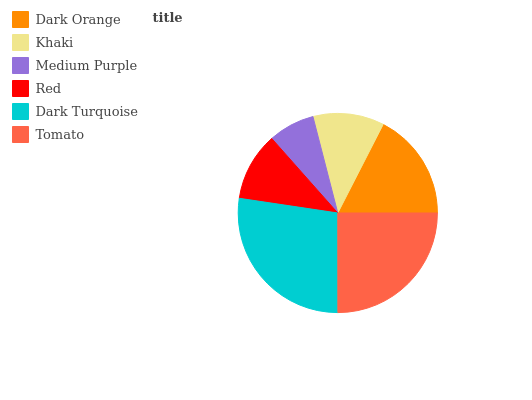Is Medium Purple the minimum?
Answer yes or no. Yes. Is Dark Turquoise the maximum?
Answer yes or no. Yes. Is Khaki the minimum?
Answer yes or no. No. Is Khaki the maximum?
Answer yes or no. No. Is Dark Orange greater than Khaki?
Answer yes or no. Yes. Is Khaki less than Dark Orange?
Answer yes or no. Yes. Is Khaki greater than Dark Orange?
Answer yes or no. No. Is Dark Orange less than Khaki?
Answer yes or no. No. Is Dark Orange the high median?
Answer yes or no. Yes. Is Khaki the low median?
Answer yes or no. Yes. Is Red the high median?
Answer yes or no. No. Is Dark Turquoise the low median?
Answer yes or no. No. 